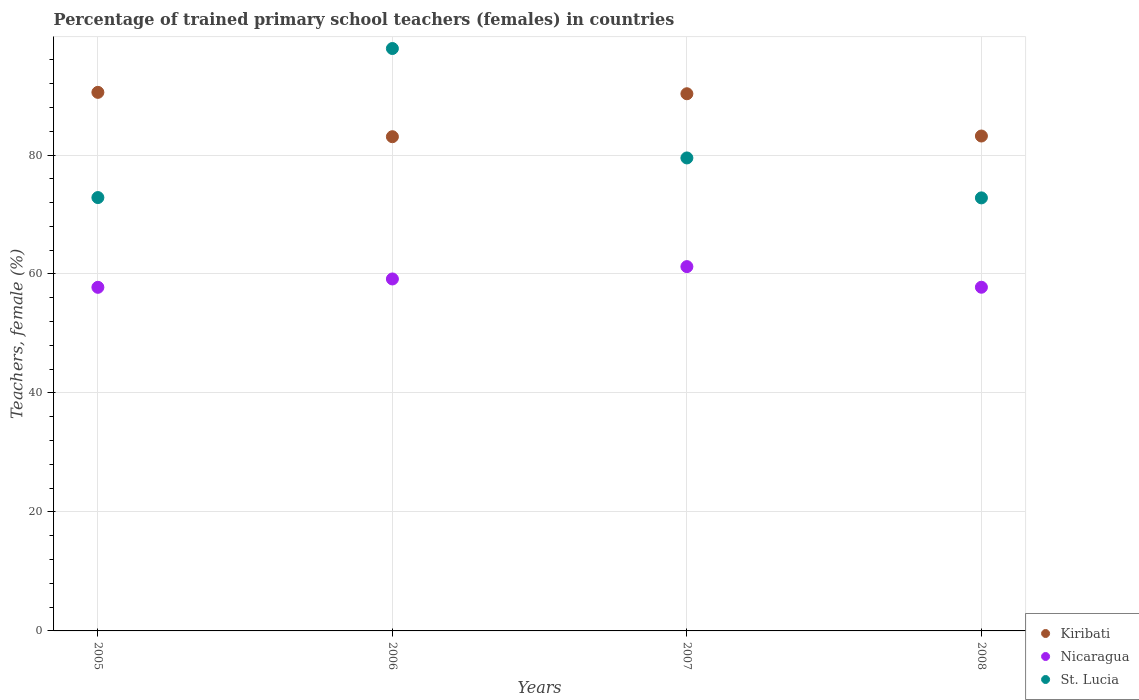Is the number of dotlines equal to the number of legend labels?
Your response must be concise. Yes. What is the percentage of trained primary school teachers (females) in St. Lucia in 2007?
Provide a short and direct response. 79.51. Across all years, what is the maximum percentage of trained primary school teachers (females) in St. Lucia?
Give a very brief answer. 97.9. Across all years, what is the minimum percentage of trained primary school teachers (females) in St. Lucia?
Offer a very short reply. 72.79. What is the total percentage of trained primary school teachers (females) in Nicaragua in the graph?
Give a very brief answer. 235.94. What is the difference between the percentage of trained primary school teachers (females) in St. Lucia in 2005 and that in 2006?
Provide a succinct answer. -25.05. What is the difference between the percentage of trained primary school teachers (females) in Nicaragua in 2006 and the percentage of trained primary school teachers (females) in St. Lucia in 2007?
Your answer should be compact. -20.34. What is the average percentage of trained primary school teachers (females) in St. Lucia per year?
Offer a very short reply. 80.76. In the year 2008, what is the difference between the percentage of trained primary school teachers (females) in St. Lucia and percentage of trained primary school teachers (females) in Kiribati?
Your response must be concise. -10.4. What is the ratio of the percentage of trained primary school teachers (females) in Nicaragua in 2005 to that in 2007?
Your response must be concise. 0.94. Is the percentage of trained primary school teachers (females) in Kiribati in 2005 less than that in 2006?
Ensure brevity in your answer.  No. Is the difference between the percentage of trained primary school teachers (females) in St. Lucia in 2005 and 2006 greater than the difference between the percentage of trained primary school teachers (females) in Kiribati in 2005 and 2006?
Your response must be concise. No. What is the difference between the highest and the second highest percentage of trained primary school teachers (females) in Nicaragua?
Your answer should be compact. 2.08. What is the difference between the highest and the lowest percentage of trained primary school teachers (females) in St. Lucia?
Provide a succinct answer. 25.11. In how many years, is the percentage of trained primary school teachers (females) in Kiribati greater than the average percentage of trained primary school teachers (females) in Kiribati taken over all years?
Provide a short and direct response. 2. Does the percentage of trained primary school teachers (females) in St. Lucia monotonically increase over the years?
Provide a succinct answer. No. Is the percentage of trained primary school teachers (females) in St. Lucia strictly greater than the percentage of trained primary school teachers (females) in Nicaragua over the years?
Your answer should be compact. Yes. Is the percentage of trained primary school teachers (females) in Kiribati strictly less than the percentage of trained primary school teachers (females) in Nicaragua over the years?
Offer a very short reply. No. How many years are there in the graph?
Provide a succinct answer. 4. What is the difference between two consecutive major ticks on the Y-axis?
Provide a short and direct response. 20. Are the values on the major ticks of Y-axis written in scientific E-notation?
Your response must be concise. No. Does the graph contain any zero values?
Give a very brief answer. No. Does the graph contain grids?
Your answer should be very brief. Yes. Where does the legend appear in the graph?
Make the answer very short. Bottom right. How many legend labels are there?
Your answer should be very brief. 3. What is the title of the graph?
Your answer should be very brief. Percentage of trained primary school teachers (females) in countries. Does "Senegal" appear as one of the legend labels in the graph?
Your response must be concise. No. What is the label or title of the Y-axis?
Give a very brief answer. Teachers, female (%). What is the Teachers, female (%) in Kiribati in 2005?
Give a very brief answer. 90.53. What is the Teachers, female (%) of Nicaragua in 2005?
Ensure brevity in your answer.  57.76. What is the Teachers, female (%) in St. Lucia in 2005?
Keep it short and to the point. 72.85. What is the Teachers, female (%) in Kiribati in 2006?
Provide a succinct answer. 83.08. What is the Teachers, female (%) in Nicaragua in 2006?
Give a very brief answer. 59.16. What is the Teachers, female (%) in St. Lucia in 2006?
Give a very brief answer. 97.9. What is the Teachers, female (%) of Kiribati in 2007?
Provide a short and direct response. 90.3. What is the Teachers, female (%) of Nicaragua in 2007?
Offer a very short reply. 61.24. What is the Teachers, female (%) of St. Lucia in 2007?
Make the answer very short. 79.51. What is the Teachers, female (%) of Kiribati in 2008?
Provide a short and direct response. 83.19. What is the Teachers, female (%) in Nicaragua in 2008?
Ensure brevity in your answer.  57.77. What is the Teachers, female (%) of St. Lucia in 2008?
Provide a succinct answer. 72.79. Across all years, what is the maximum Teachers, female (%) in Kiribati?
Ensure brevity in your answer.  90.53. Across all years, what is the maximum Teachers, female (%) of Nicaragua?
Keep it short and to the point. 61.24. Across all years, what is the maximum Teachers, female (%) in St. Lucia?
Your response must be concise. 97.9. Across all years, what is the minimum Teachers, female (%) of Kiribati?
Offer a terse response. 83.08. Across all years, what is the minimum Teachers, female (%) in Nicaragua?
Your response must be concise. 57.76. Across all years, what is the minimum Teachers, female (%) of St. Lucia?
Your answer should be very brief. 72.79. What is the total Teachers, female (%) of Kiribati in the graph?
Ensure brevity in your answer.  347.1. What is the total Teachers, female (%) in Nicaragua in the graph?
Provide a short and direct response. 235.94. What is the total Teachers, female (%) in St. Lucia in the graph?
Offer a very short reply. 323.05. What is the difference between the Teachers, female (%) of Kiribati in 2005 and that in 2006?
Your answer should be very brief. 7.46. What is the difference between the Teachers, female (%) in Nicaragua in 2005 and that in 2006?
Your answer should be compact. -1.4. What is the difference between the Teachers, female (%) of St. Lucia in 2005 and that in 2006?
Make the answer very short. -25.05. What is the difference between the Teachers, female (%) in Kiribati in 2005 and that in 2007?
Provide a succinct answer. 0.23. What is the difference between the Teachers, female (%) of Nicaragua in 2005 and that in 2007?
Offer a terse response. -3.48. What is the difference between the Teachers, female (%) in St. Lucia in 2005 and that in 2007?
Ensure brevity in your answer.  -6.66. What is the difference between the Teachers, female (%) in Kiribati in 2005 and that in 2008?
Ensure brevity in your answer.  7.34. What is the difference between the Teachers, female (%) of Nicaragua in 2005 and that in 2008?
Your response must be concise. -0.01. What is the difference between the Teachers, female (%) of St. Lucia in 2005 and that in 2008?
Offer a terse response. 0.05. What is the difference between the Teachers, female (%) in Kiribati in 2006 and that in 2007?
Give a very brief answer. -7.22. What is the difference between the Teachers, female (%) of Nicaragua in 2006 and that in 2007?
Keep it short and to the point. -2.08. What is the difference between the Teachers, female (%) in St. Lucia in 2006 and that in 2007?
Make the answer very short. 18.39. What is the difference between the Teachers, female (%) of Kiribati in 2006 and that in 2008?
Your answer should be compact. -0.12. What is the difference between the Teachers, female (%) of Nicaragua in 2006 and that in 2008?
Provide a short and direct response. 1.39. What is the difference between the Teachers, female (%) in St. Lucia in 2006 and that in 2008?
Your response must be concise. 25.11. What is the difference between the Teachers, female (%) of Kiribati in 2007 and that in 2008?
Keep it short and to the point. 7.11. What is the difference between the Teachers, female (%) in Nicaragua in 2007 and that in 2008?
Give a very brief answer. 3.47. What is the difference between the Teachers, female (%) of St. Lucia in 2007 and that in 2008?
Make the answer very short. 6.71. What is the difference between the Teachers, female (%) in Kiribati in 2005 and the Teachers, female (%) in Nicaragua in 2006?
Ensure brevity in your answer.  31.37. What is the difference between the Teachers, female (%) in Kiribati in 2005 and the Teachers, female (%) in St. Lucia in 2006?
Offer a very short reply. -7.37. What is the difference between the Teachers, female (%) of Nicaragua in 2005 and the Teachers, female (%) of St. Lucia in 2006?
Your answer should be compact. -40.14. What is the difference between the Teachers, female (%) in Kiribati in 2005 and the Teachers, female (%) in Nicaragua in 2007?
Provide a succinct answer. 29.29. What is the difference between the Teachers, female (%) in Kiribati in 2005 and the Teachers, female (%) in St. Lucia in 2007?
Keep it short and to the point. 11.02. What is the difference between the Teachers, female (%) in Nicaragua in 2005 and the Teachers, female (%) in St. Lucia in 2007?
Provide a short and direct response. -21.75. What is the difference between the Teachers, female (%) in Kiribati in 2005 and the Teachers, female (%) in Nicaragua in 2008?
Offer a terse response. 32.76. What is the difference between the Teachers, female (%) in Kiribati in 2005 and the Teachers, female (%) in St. Lucia in 2008?
Your answer should be compact. 17.74. What is the difference between the Teachers, female (%) of Nicaragua in 2005 and the Teachers, female (%) of St. Lucia in 2008?
Your response must be concise. -15.03. What is the difference between the Teachers, female (%) in Kiribati in 2006 and the Teachers, female (%) in Nicaragua in 2007?
Give a very brief answer. 21.84. What is the difference between the Teachers, female (%) in Kiribati in 2006 and the Teachers, female (%) in St. Lucia in 2007?
Ensure brevity in your answer.  3.57. What is the difference between the Teachers, female (%) of Nicaragua in 2006 and the Teachers, female (%) of St. Lucia in 2007?
Give a very brief answer. -20.34. What is the difference between the Teachers, female (%) of Kiribati in 2006 and the Teachers, female (%) of Nicaragua in 2008?
Give a very brief answer. 25.3. What is the difference between the Teachers, female (%) in Kiribati in 2006 and the Teachers, female (%) in St. Lucia in 2008?
Keep it short and to the point. 10.28. What is the difference between the Teachers, female (%) in Nicaragua in 2006 and the Teachers, female (%) in St. Lucia in 2008?
Provide a short and direct response. -13.63. What is the difference between the Teachers, female (%) of Kiribati in 2007 and the Teachers, female (%) of Nicaragua in 2008?
Your response must be concise. 32.53. What is the difference between the Teachers, female (%) in Kiribati in 2007 and the Teachers, female (%) in St. Lucia in 2008?
Provide a short and direct response. 17.5. What is the difference between the Teachers, female (%) of Nicaragua in 2007 and the Teachers, female (%) of St. Lucia in 2008?
Ensure brevity in your answer.  -11.55. What is the average Teachers, female (%) of Kiribati per year?
Ensure brevity in your answer.  86.78. What is the average Teachers, female (%) in Nicaragua per year?
Your answer should be very brief. 58.98. What is the average Teachers, female (%) of St. Lucia per year?
Provide a short and direct response. 80.76. In the year 2005, what is the difference between the Teachers, female (%) of Kiribati and Teachers, female (%) of Nicaragua?
Your answer should be compact. 32.77. In the year 2005, what is the difference between the Teachers, female (%) in Kiribati and Teachers, female (%) in St. Lucia?
Provide a short and direct response. 17.68. In the year 2005, what is the difference between the Teachers, female (%) in Nicaragua and Teachers, female (%) in St. Lucia?
Ensure brevity in your answer.  -15.09. In the year 2006, what is the difference between the Teachers, female (%) of Kiribati and Teachers, female (%) of Nicaragua?
Provide a succinct answer. 23.91. In the year 2006, what is the difference between the Teachers, female (%) of Kiribati and Teachers, female (%) of St. Lucia?
Make the answer very short. -14.83. In the year 2006, what is the difference between the Teachers, female (%) in Nicaragua and Teachers, female (%) in St. Lucia?
Your answer should be compact. -38.74. In the year 2007, what is the difference between the Teachers, female (%) in Kiribati and Teachers, female (%) in Nicaragua?
Offer a terse response. 29.06. In the year 2007, what is the difference between the Teachers, female (%) in Kiribati and Teachers, female (%) in St. Lucia?
Offer a terse response. 10.79. In the year 2007, what is the difference between the Teachers, female (%) in Nicaragua and Teachers, female (%) in St. Lucia?
Give a very brief answer. -18.27. In the year 2008, what is the difference between the Teachers, female (%) in Kiribati and Teachers, female (%) in Nicaragua?
Provide a short and direct response. 25.42. In the year 2008, what is the difference between the Teachers, female (%) in Kiribati and Teachers, female (%) in St. Lucia?
Provide a short and direct response. 10.4. In the year 2008, what is the difference between the Teachers, female (%) of Nicaragua and Teachers, female (%) of St. Lucia?
Offer a very short reply. -15.02. What is the ratio of the Teachers, female (%) in Kiribati in 2005 to that in 2006?
Your response must be concise. 1.09. What is the ratio of the Teachers, female (%) in Nicaragua in 2005 to that in 2006?
Your answer should be compact. 0.98. What is the ratio of the Teachers, female (%) of St. Lucia in 2005 to that in 2006?
Provide a succinct answer. 0.74. What is the ratio of the Teachers, female (%) of Kiribati in 2005 to that in 2007?
Your answer should be very brief. 1. What is the ratio of the Teachers, female (%) in Nicaragua in 2005 to that in 2007?
Provide a short and direct response. 0.94. What is the ratio of the Teachers, female (%) of St. Lucia in 2005 to that in 2007?
Offer a terse response. 0.92. What is the ratio of the Teachers, female (%) of Kiribati in 2005 to that in 2008?
Offer a terse response. 1.09. What is the ratio of the Teachers, female (%) in Nicaragua in 2005 to that in 2008?
Give a very brief answer. 1. What is the ratio of the Teachers, female (%) in St. Lucia in 2005 to that in 2008?
Ensure brevity in your answer.  1. What is the ratio of the Teachers, female (%) of Nicaragua in 2006 to that in 2007?
Your answer should be compact. 0.97. What is the ratio of the Teachers, female (%) of St. Lucia in 2006 to that in 2007?
Keep it short and to the point. 1.23. What is the ratio of the Teachers, female (%) of Nicaragua in 2006 to that in 2008?
Your answer should be compact. 1.02. What is the ratio of the Teachers, female (%) of St. Lucia in 2006 to that in 2008?
Your answer should be very brief. 1.34. What is the ratio of the Teachers, female (%) in Kiribati in 2007 to that in 2008?
Your response must be concise. 1.09. What is the ratio of the Teachers, female (%) of Nicaragua in 2007 to that in 2008?
Provide a short and direct response. 1.06. What is the ratio of the Teachers, female (%) of St. Lucia in 2007 to that in 2008?
Make the answer very short. 1.09. What is the difference between the highest and the second highest Teachers, female (%) in Kiribati?
Give a very brief answer. 0.23. What is the difference between the highest and the second highest Teachers, female (%) of Nicaragua?
Offer a terse response. 2.08. What is the difference between the highest and the second highest Teachers, female (%) in St. Lucia?
Keep it short and to the point. 18.39. What is the difference between the highest and the lowest Teachers, female (%) in Kiribati?
Your response must be concise. 7.46. What is the difference between the highest and the lowest Teachers, female (%) of Nicaragua?
Provide a succinct answer. 3.48. What is the difference between the highest and the lowest Teachers, female (%) in St. Lucia?
Provide a short and direct response. 25.11. 